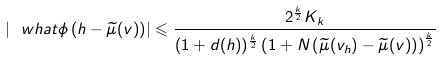Convert formula to latex. <formula><loc_0><loc_0><loc_500><loc_500>\left | \ w h a t \phi \left ( h - \widetilde { \mu } ( v ) \right ) \right | \leqslant \frac { 2 ^ { \frac { k } { 2 } } K _ { k } } { ( 1 + d ( h ) ) ^ { \frac { k } { 2 } } \left ( 1 + N \left ( \widetilde { \mu } ( v _ { h } ) - \widetilde { \mu } ( v ) \right ) \right ) ^ { \frac { k } { 2 } } }</formula> 